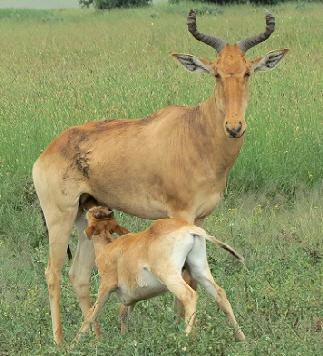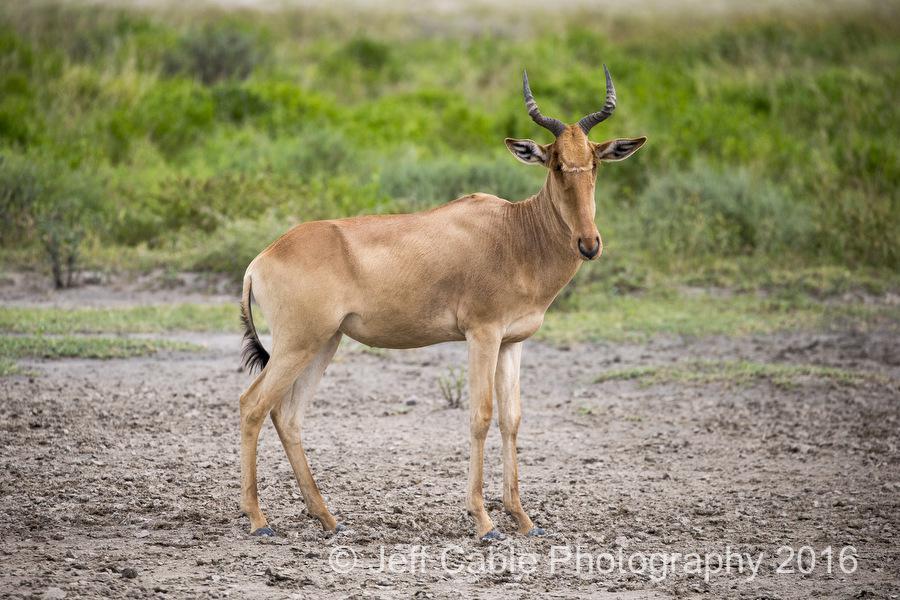The first image is the image on the left, the second image is the image on the right. Given the left and right images, does the statement "At least one image includes a young animal and an adult with horns." hold true? Answer yes or no. Yes. 